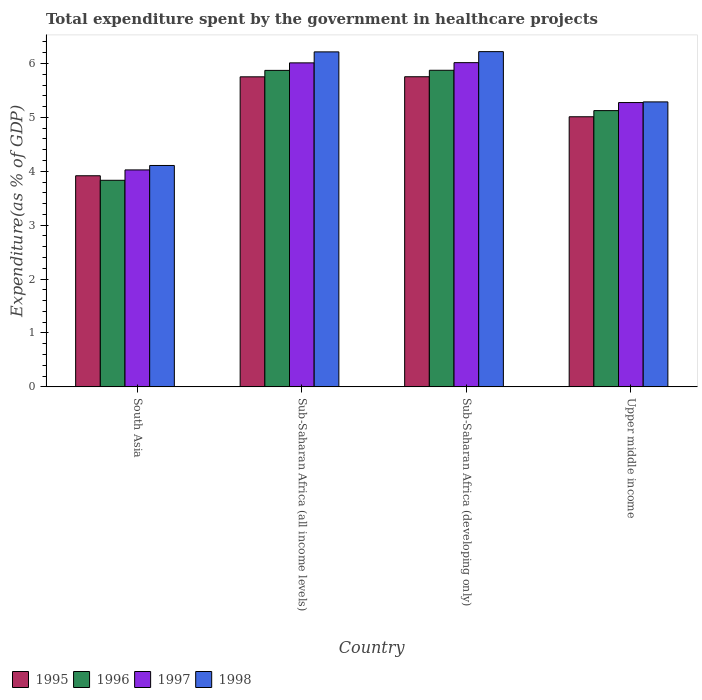How many groups of bars are there?
Keep it short and to the point. 4. How many bars are there on the 3rd tick from the left?
Provide a succinct answer. 4. How many bars are there on the 4th tick from the right?
Keep it short and to the point. 4. What is the label of the 3rd group of bars from the left?
Offer a very short reply. Sub-Saharan Africa (developing only). What is the total expenditure spent by the government in healthcare projects in 1997 in Sub-Saharan Africa (all income levels)?
Offer a very short reply. 6.01. Across all countries, what is the maximum total expenditure spent by the government in healthcare projects in 1996?
Your answer should be compact. 5.87. Across all countries, what is the minimum total expenditure spent by the government in healthcare projects in 1998?
Provide a succinct answer. 4.11. In which country was the total expenditure spent by the government in healthcare projects in 1996 maximum?
Your answer should be very brief. Sub-Saharan Africa (developing only). In which country was the total expenditure spent by the government in healthcare projects in 1996 minimum?
Provide a succinct answer. South Asia. What is the total total expenditure spent by the government in healthcare projects in 1998 in the graph?
Provide a short and direct response. 21.83. What is the difference between the total expenditure spent by the government in healthcare projects in 1998 in South Asia and that in Sub-Saharan Africa (developing only)?
Give a very brief answer. -2.11. What is the difference between the total expenditure spent by the government in healthcare projects in 1996 in Upper middle income and the total expenditure spent by the government in healthcare projects in 1997 in Sub-Saharan Africa (all income levels)?
Make the answer very short. -0.89. What is the average total expenditure spent by the government in healthcare projects in 1997 per country?
Your answer should be compact. 5.33. What is the difference between the total expenditure spent by the government in healthcare projects of/in 1995 and total expenditure spent by the government in healthcare projects of/in 1996 in Sub-Saharan Africa (all income levels)?
Your answer should be compact. -0.12. What is the ratio of the total expenditure spent by the government in healthcare projects in 1996 in South Asia to that in Sub-Saharan Africa (all income levels)?
Offer a terse response. 0.65. Is the total expenditure spent by the government in healthcare projects in 1998 in Sub-Saharan Africa (developing only) less than that in Upper middle income?
Provide a succinct answer. No. Is the difference between the total expenditure spent by the government in healthcare projects in 1995 in Sub-Saharan Africa (developing only) and Upper middle income greater than the difference between the total expenditure spent by the government in healthcare projects in 1996 in Sub-Saharan Africa (developing only) and Upper middle income?
Ensure brevity in your answer.  No. What is the difference between the highest and the second highest total expenditure spent by the government in healthcare projects in 1995?
Keep it short and to the point. -0.74. What is the difference between the highest and the lowest total expenditure spent by the government in healthcare projects in 1998?
Make the answer very short. 2.11. What does the 2nd bar from the left in South Asia represents?
Your response must be concise. 1996. What does the 4th bar from the right in Sub-Saharan Africa (all income levels) represents?
Ensure brevity in your answer.  1995. What is the difference between two consecutive major ticks on the Y-axis?
Give a very brief answer. 1. Are the values on the major ticks of Y-axis written in scientific E-notation?
Provide a succinct answer. No. Does the graph contain any zero values?
Offer a very short reply. No. What is the title of the graph?
Make the answer very short. Total expenditure spent by the government in healthcare projects. What is the label or title of the X-axis?
Make the answer very short. Country. What is the label or title of the Y-axis?
Your answer should be compact. Expenditure(as % of GDP). What is the Expenditure(as % of GDP) in 1995 in South Asia?
Your answer should be compact. 3.92. What is the Expenditure(as % of GDP) of 1996 in South Asia?
Make the answer very short. 3.83. What is the Expenditure(as % of GDP) of 1997 in South Asia?
Offer a terse response. 4.03. What is the Expenditure(as % of GDP) in 1998 in South Asia?
Keep it short and to the point. 4.11. What is the Expenditure(as % of GDP) in 1995 in Sub-Saharan Africa (all income levels)?
Make the answer very short. 5.75. What is the Expenditure(as % of GDP) of 1996 in Sub-Saharan Africa (all income levels)?
Offer a terse response. 5.87. What is the Expenditure(as % of GDP) of 1997 in Sub-Saharan Africa (all income levels)?
Give a very brief answer. 6.01. What is the Expenditure(as % of GDP) in 1998 in Sub-Saharan Africa (all income levels)?
Give a very brief answer. 6.22. What is the Expenditure(as % of GDP) of 1995 in Sub-Saharan Africa (developing only)?
Keep it short and to the point. 5.75. What is the Expenditure(as % of GDP) in 1996 in Sub-Saharan Africa (developing only)?
Make the answer very short. 5.87. What is the Expenditure(as % of GDP) in 1997 in Sub-Saharan Africa (developing only)?
Provide a short and direct response. 6.02. What is the Expenditure(as % of GDP) of 1998 in Sub-Saharan Africa (developing only)?
Your answer should be very brief. 6.22. What is the Expenditure(as % of GDP) in 1995 in Upper middle income?
Keep it short and to the point. 5.01. What is the Expenditure(as % of GDP) of 1996 in Upper middle income?
Your answer should be very brief. 5.13. What is the Expenditure(as % of GDP) of 1997 in Upper middle income?
Provide a short and direct response. 5.28. What is the Expenditure(as % of GDP) of 1998 in Upper middle income?
Provide a succinct answer. 5.29. Across all countries, what is the maximum Expenditure(as % of GDP) of 1995?
Your response must be concise. 5.75. Across all countries, what is the maximum Expenditure(as % of GDP) in 1996?
Keep it short and to the point. 5.87. Across all countries, what is the maximum Expenditure(as % of GDP) of 1997?
Give a very brief answer. 6.02. Across all countries, what is the maximum Expenditure(as % of GDP) of 1998?
Ensure brevity in your answer.  6.22. Across all countries, what is the minimum Expenditure(as % of GDP) in 1995?
Offer a terse response. 3.92. Across all countries, what is the minimum Expenditure(as % of GDP) of 1996?
Provide a short and direct response. 3.83. Across all countries, what is the minimum Expenditure(as % of GDP) in 1997?
Keep it short and to the point. 4.03. Across all countries, what is the minimum Expenditure(as % of GDP) in 1998?
Your answer should be compact. 4.11. What is the total Expenditure(as % of GDP) in 1995 in the graph?
Your answer should be compact. 20.44. What is the total Expenditure(as % of GDP) of 1996 in the graph?
Make the answer very short. 20.71. What is the total Expenditure(as % of GDP) of 1997 in the graph?
Make the answer very short. 21.33. What is the total Expenditure(as % of GDP) of 1998 in the graph?
Your response must be concise. 21.83. What is the difference between the Expenditure(as % of GDP) of 1995 in South Asia and that in Sub-Saharan Africa (all income levels)?
Ensure brevity in your answer.  -1.84. What is the difference between the Expenditure(as % of GDP) of 1996 in South Asia and that in Sub-Saharan Africa (all income levels)?
Provide a short and direct response. -2.04. What is the difference between the Expenditure(as % of GDP) of 1997 in South Asia and that in Sub-Saharan Africa (all income levels)?
Your answer should be very brief. -1.99. What is the difference between the Expenditure(as % of GDP) in 1998 in South Asia and that in Sub-Saharan Africa (all income levels)?
Your answer should be compact. -2.11. What is the difference between the Expenditure(as % of GDP) in 1995 in South Asia and that in Sub-Saharan Africa (developing only)?
Make the answer very short. -1.84. What is the difference between the Expenditure(as % of GDP) in 1996 in South Asia and that in Sub-Saharan Africa (developing only)?
Offer a terse response. -2.04. What is the difference between the Expenditure(as % of GDP) in 1997 in South Asia and that in Sub-Saharan Africa (developing only)?
Offer a very short reply. -1.99. What is the difference between the Expenditure(as % of GDP) of 1998 in South Asia and that in Sub-Saharan Africa (developing only)?
Provide a succinct answer. -2.11. What is the difference between the Expenditure(as % of GDP) in 1995 in South Asia and that in Upper middle income?
Provide a succinct answer. -1.09. What is the difference between the Expenditure(as % of GDP) of 1996 in South Asia and that in Upper middle income?
Offer a terse response. -1.29. What is the difference between the Expenditure(as % of GDP) of 1997 in South Asia and that in Upper middle income?
Keep it short and to the point. -1.25. What is the difference between the Expenditure(as % of GDP) of 1998 in South Asia and that in Upper middle income?
Keep it short and to the point. -1.18. What is the difference between the Expenditure(as % of GDP) in 1995 in Sub-Saharan Africa (all income levels) and that in Sub-Saharan Africa (developing only)?
Offer a very short reply. -0. What is the difference between the Expenditure(as % of GDP) of 1996 in Sub-Saharan Africa (all income levels) and that in Sub-Saharan Africa (developing only)?
Provide a short and direct response. -0. What is the difference between the Expenditure(as % of GDP) of 1997 in Sub-Saharan Africa (all income levels) and that in Sub-Saharan Africa (developing only)?
Ensure brevity in your answer.  -0. What is the difference between the Expenditure(as % of GDP) of 1998 in Sub-Saharan Africa (all income levels) and that in Sub-Saharan Africa (developing only)?
Give a very brief answer. -0. What is the difference between the Expenditure(as % of GDP) of 1995 in Sub-Saharan Africa (all income levels) and that in Upper middle income?
Your response must be concise. 0.74. What is the difference between the Expenditure(as % of GDP) in 1996 in Sub-Saharan Africa (all income levels) and that in Upper middle income?
Provide a succinct answer. 0.75. What is the difference between the Expenditure(as % of GDP) in 1997 in Sub-Saharan Africa (all income levels) and that in Upper middle income?
Your answer should be compact. 0.74. What is the difference between the Expenditure(as % of GDP) of 1998 in Sub-Saharan Africa (all income levels) and that in Upper middle income?
Provide a succinct answer. 0.93. What is the difference between the Expenditure(as % of GDP) of 1995 in Sub-Saharan Africa (developing only) and that in Upper middle income?
Make the answer very short. 0.74. What is the difference between the Expenditure(as % of GDP) in 1996 in Sub-Saharan Africa (developing only) and that in Upper middle income?
Offer a terse response. 0.75. What is the difference between the Expenditure(as % of GDP) of 1997 in Sub-Saharan Africa (developing only) and that in Upper middle income?
Provide a short and direct response. 0.74. What is the difference between the Expenditure(as % of GDP) of 1998 in Sub-Saharan Africa (developing only) and that in Upper middle income?
Provide a short and direct response. 0.93. What is the difference between the Expenditure(as % of GDP) in 1995 in South Asia and the Expenditure(as % of GDP) in 1996 in Sub-Saharan Africa (all income levels)?
Make the answer very short. -1.96. What is the difference between the Expenditure(as % of GDP) in 1995 in South Asia and the Expenditure(as % of GDP) in 1997 in Sub-Saharan Africa (all income levels)?
Your answer should be compact. -2.09. What is the difference between the Expenditure(as % of GDP) of 1995 in South Asia and the Expenditure(as % of GDP) of 1998 in Sub-Saharan Africa (all income levels)?
Give a very brief answer. -2.3. What is the difference between the Expenditure(as % of GDP) of 1996 in South Asia and the Expenditure(as % of GDP) of 1997 in Sub-Saharan Africa (all income levels)?
Make the answer very short. -2.18. What is the difference between the Expenditure(as % of GDP) of 1996 in South Asia and the Expenditure(as % of GDP) of 1998 in Sub-Saharan Africa (all income levels)?
Provide a succinct answer. -2.38. What is the difference between the Expenditure(as % of GDP) of 1997 in South Asia and the Expenditure(as % of GDP) of 1998 in Sub-Saharan Africa (all income levels)?
Provide a succinct answer. -2.19. What is the difference between the Expenditure(as % of GDP) of 1995 in South Asia and the Expenditure(as % of GDP) of 1996 in Sub-Saharan Africa (developing only)?
Your answer should be very brief. -1.96. What is the difference between the Expenditure(as % of GDP) in 1995 in South Asia and the Expenditure(as % of GDP) in 1997 in Sub-Saharan Africa (developing only)?
Ensure brevity in your answer.  -2.1. What is the difference between the Expenditure(as % of GDP) of 1995 in South Asia and the Expenditure(as % of GDP) of 1998 in Sub-Saharan Africa (developing only)?
Offer a terse response. -2.3. What is the difference between the Expenditure(as % of GDP) of 1996 in South Asia and the Expenditure(as % of GDP) of 1997 in Sub-Saharan Africa (developing only)?
Give a very brief answer. -2.18. What is the difference between the Expenditure(as % of GDP) of 1996 in South Asia and the Expenditure(as % of GDP) of 1998 in Sub-Saharan Africa (developing only)?
Provide a succinct answer. -2.39. What is the difference between the Expenditure(as % of GDP) in 1997 in South Asia and the Expenditure(as % of GDP) in 1998 in Sub-Saharan Africa (developing only)?
Make the answer very short. -2.19. What is the difference between the Expenditure(as % of GDP) in 1995 in South Asia and the Expenditure(as % of GDP) in 1996 in Upper middle income?
Offer a very short reply. -1.21. What is the difference between the Expenditure(as % of GDP) of 1995 in South Asia and the Expenditure(as % of GDP) of 1997 in Upper middle income?
Offer a terse response. -1.36. What is the difference between the Expenditure(as % of GDP) in 1995 in South Asia and the Expenditure(as % of GDP) in 1998 in Upper middle income?
Your answer should be compact. -1.37. What is the difference between the Expenditure(as % of GDP) in 1996 in South Asia and the Expenditure(as % of GDP) in 1997 in Upper middle income?
Provide a succinct answer. -1.44. What is the difference between the Expenditure(as % of GDP) of 1996 in South Asia and the Expenditure(as % of GDP) of 1998 in Upper middle income?
Your answer should be compact. -1.45. What is the difference between the Expenditure(as % of GDP) in 1997 in South Asia and the Expenditure(as % of GDP) in 1998 in Upper middle income?
Your answer should be compact. -1.26. What is the difference between the Expenditure(as % of GDP) in 1995 in Sub-Saharan Africa (all income levels) and the Expenditure(as % of GDP) in 1996 in Sub-Saharan Africa (developing only)?
Provide a succinct answer. -0.12. What is the difference between the Expenditure(as % of GDP) of 1995 in Sub-Saharan Africa (all income levels) and the Expenditure(as % of GDP) of 1997 in Sub-Saharan Africa (developing only)?
Give a very brief answer. -0.26. What is the difference between the Expenditure(as % of GDP) in 1995 in Sub-Saharan Africa (all income levels) and the Expenditure(as % of GDP) in 1998 in Sub-Saharan Africa (developing only)?
Make the answer very short. -0.47. What is the difference between the Expenditure(as % of GDP) in 1996 in Sub-Saharan Africa (all income levels) and the Expenditure(as % of GDP) in 1997 in Sub-Saharan Africa (developing only)?
Your answer should be very brief. -0.14. What is the difference between the Expenditure(as % of GDP) in 1996 in Sub-Saharan Africa (all income levels) and the Expenditure(as % of GDP) in 1998 in Sub-Saharan Africa (developing only)?
Provide a short and direct response. -0.35. What is the difference between the Expenditure(as % of GDP) in 1997 in Sub-Saharan Africa (all income levels) and the Expenditure(as % of GDP) in 1998 in Sub-Saharan Africa (developing only)?
Offer a terse response. -0.21. What is the difference between the Expenditure(as % of GDP) of 1995 in Sub-Saharan Africa (all income levels) and the Expenditure(as % of GDP) of 1996 in Upper middle income?
Keep it short and to the point. 0.63. What is the difference between the Expenditure(as % of GDP) in 1995 in Sub-Saharan Africa (all income levels) and the Expenditure(as % of GDP) in 1997 in Upper middle income?
Provide a short and direct response. 0.48. What is the difference between the Expenditure(as % of GDP) of 1995 in Sub-Saharan Africa (all income levels) and the Expenditure(as % of GDP) of 1998 in Upper middle income?
Give a very brief answer. 0.47. What is the difference between the Expenditure(as % of GDP) in 1996 in Sub-Saharan Africa (all income levels) and the Expenditure(as % of GDP) in 1997 in Upper middle income?
Make the answer very short. 0.6. What is the difference between the Expenditure(as % of GDP) of 1996 in Sub-Saharan Africa (all income levels) and the Expenditure(as % of GDP) of 1998 in Upper middle income?
Ensure brevity in your answer.  0.58. What is the difference between the Expenditure(as % of GDP) in 1997 in Sub-Saharan Africa (all income levels) and the Expenditure(as % of GDP) in 1998 in Upper middle income?
Provide a short and direct response. 0.72. What is the difference between the Expenditure(as % of GDP) in 1995 in Sub-Saharan Africa (developing only) and the Expenditure(as % of GDP) in 1996 in Upper middle income?
Your answer should be very brief. 0.63. What is the difference between the Expenditure(as % of GDP) of 1995 in Sub-Saharan Africa (developing only) and the Expenditure(as % of GDP) of 1997 in Upper middle income?
Your answer should be compact. 0.48. What is the difference between the Expenditure(as % of GDP) in 1995 in Sub-Saharan Africa (developing only) and the Expenditure(as % of GDP) in 1998 in Upper middle income?
Keep it short and to the point. 0.47. What is the difference between the Expenditure(as % of GDP) in 1996 in Sub-Saharan Africa (developing only) and the Expenditure(as % of GDP) in 1997 in Upper middle income?
Give a very brief answer. 0.6. What is the difference between the Expenditure(as % of GDP) in 1996 in Sub-Saharan Africa (developing only) and the Expenditure(as % of GDP) in 1998 in Upper middle income?
Ensure brevity in your answer.  0.59. What is the difference between the Expenditure(as % of GDP) in 1997 in Sub-Saharan Africa (developing only) and the Expenditure(as % of GDP) in 1998 in Upper middle income?
Provide a succinct answer. 0.73. What is the average Expenditure(as % of GDP) in 1995 per country?
Keep it short and to the point. 5.11. What is the average Expenditure(as % of GDP) in 1996 per country?
Offer a terse response. 5.18. What is the average Expenditure(as % of GDP) of 1997 per country?
Ensure brevity in your answer.  5.33. What is the average Expenditure(as % of GDP) in 1998 per country?
Your response must be concise. 5.46. What is the difference between the Expenditure(as % of GDP) in 1995 and Expenditure(as % of GDP) in 1996 in South Asia?
Give a very brief answer. 0.08. What is the difference between the Expenditure(as % of GDP) in 1995 and Expenditure(as % of GDP) in 1997 in South Asia?
Make the answer very short. -0.11. What is the difference between the Expenditure(as % of GDP) in 1995 and Expenditure(as % of GDP) in 1998 in South Asia?
Keep it short and to the point. -0.19. What is the difference between the Expenditure(as % of GDP) in 1996 and Expenditure(as % of GDP) in 1997 in South Asia?
Keep it short and to the point. -0.19. What is the difference between the Expenditure(as % of GDP) of 1996 and Expenditure(as % of GDP) of 1998 in South Asia?
Keep it short and to the point. -0.27. What is the difference between the Expenditure(as % of GDP) in 1997 and Expenditure(as % of GDP) in 1998 in South Asia?
Your answer should be very brief. -0.08. What is the difference between the Expenditure(as % of GDP) in 1995 and Expenditure(as % of GDP) in 1996 in Sub-Saharan Africa (all income levels)?
Keep it short and to the point. -0.12. What is the difference between the Expenditure(as % of GDP) of 1995 and Expenditure(as % of GDP) of 1997 in Sub-Saharan Africa (all income levels)?
Make the answer very short. -0.26. What is the difference between the Expenditure(as % of GDP) in 1995 and Expenditure(as % of GDP) in 1998 in Sub-Saharan Africa (all income levels)?
Ensure brevity in your answer.  -0.46. What is the difference between the Expenditure(as % of GDP) in 1996 and Expenditure(as % of GDP) in 1997 in Sub-Saharan Africa (all income levels)?
Your answer should be very brief. -0.14. What is the difference between the Expenditure(as % of GDP) in 1996 and Expenditure(as % of GDP) in 1998 in Sub-Saharan Africa (all income levels)?
Ensure brevity in your answer.  -0.34. What is the difference between the Expenditure(as % of GDP) in 1997 and Expenditure(as % of GDP) in 1998 in Sub-Saharan Africa (all income levels)?
Provide a short and direct response. -0.2. What is the difference between the Expenditure(as % of GDP) in 1995 and Expenditure(as % of GDP) in 1996 in Sub-Saharan Africa (developing only)?
Offer a terse response. -0.12. What is the difference between the Expenditure(as % of GDP) in 1995 and Expenditure(as % of GDP) in 1997 in Sub-Saharan Africa (developing only)?
Your answer should be very brief. -0.26. What is the difference between the Expenditure(as % of GDP) of 1995 and Expenditure(as % of GDP) of 1998 in Sub-Saharan Africa (developing only)?
Your answer should be compact. -0.47. What is the difference between the Expenditure(as % of GDP) in 1996 and Expenditure(as % of GDP) in 1997 in Sub-Saharan Africa (developing only)?
Provide a succinct answer. -0.14. What is the difference between the Expenditure(as % of GDP) of 1996 and Expenditure(as % of GDP) of 1998 in Sub-Saharan Africa (developing only)?
Your answer should be very brief. -0.35. What is the difference between the Expenditure(as % of GDP) in 1997 and Expenditure(as % of GDP) in 1998 in Sub-Saharan Africa (developing only)?
Give a very brief answer. -0.2. What is the difference between the Expenditure(as % of GDP) of 1995 and Expenditure(as % of GDP) of 1996 in Upper middle income?
Provide a succinct answer. -0.11. What is the difference between the Expenditure(as % of GDP) in 1995 and Expenditure(as % of GDP) in 1997 in Upper middle income?
Your response must be concise. -0.26. What is the difference between the Expenditure(as % of GDP) of 1995 and Expenditure(as % of GDP) of 1998 in Upper middle income?
Ensure brevity in your answer.  -0.28. What is the difference between the Expenditure(as % of GDP) of 1996 and Expenditure(as % of GDP) of 1997 in Upper middle income?
Offer a very short reply. -0.15. What is the difference between the Expenditure(as % of GDP) in 1996 and Expenditure(as % of GDP) in 1998 in Upper middle income?
Give a very brief answer. -0.16. What is the difference between the Expenditure(as % of GDP) in 1997 and Expenditure(as % of GDP) in 1998 in Upper middle income?
Your answer should be very brief. -0.01. What is the ratio of the Expenditure(as % of GDP) of 1995 in South Asia to that in Sub-Saharan Africa (all income levels)?
Make the answer very short. 0.68. What is the ratio of the Expenditure(as % of GDP) of 1996 in South Asia to that in Sub-Saharan Africa (all income levels)?
Make the answer very short. 0.65. What is the ratio of the Expenditure(as % of GDP) of 1997 in South Asia to that in Sub-Saharan Africa (all income levels)?
Your answer should be compact. 0.67. What is the ratio of the Expenditure(as % of GDP) of 1998 in South Asia to that in Sub-Saharan Africa (all income levels)?
Offer a terse response. 0.66. What is the ratio of the Expenditure(as % of GDP) of 1995 in South Asia to that in Sub-Saharan Africa (developing only)?
Provide a short and direct response. 0.68. What is the ratio of the Expenditure(as % of GDP) in 1996 in South Asia to that in Sub-Saharan Africa (developing only)?
Make the answer very short. 0.65. What is the ratio of the Expenditure(as % of GDP) in 1997 in South Asia to that in Sub-Saharan Africa (developing only)?
Ensure brevity in your answer.  0.67. What is the ratio of the Expenditure(as % of GDP) in 1998 in South Asia to that in Sub-Saharan Africa (developing only)?
Make the answer very short. 0.66. What is the ratio of the Expenditure(as % of GDP) in 1995 in South Asia to that in Upper middle income?
Provide a short and direct response. 0.78. What is the ratio of the Expenditure(as % of GDP) of 1996 in South Asia to that in Upper middle income?
Give a very brief answer. 0.75. What is the ratio of the Expenditure(as % of GDP) of 1997 in South Asia to that in Upper middle income?
Offer a terse response. 0.76. What is the ratio of the Expenditure(as % of GDP) of 1998 in South Asia to that in Upper middle income?
Offer a terse response. 0.78. What is the ratio of the Expenditure(as % of GDP) of 1995 in Sub-Saharan Africa (all income levels) to that in Sub-Saharan Africa (developing only)?
Your answer should be very brief. 1. What is the ratio of the Expenditure(as % of GDP) of 1998 in Sub-Saharan Africa (all income levels) to that in Sub-Saharan Africa (developing only)?
Ensure brevity in your answer.  1. What is the ratio of the Expenditure(as % of GDP) of 1995 in Sub-Saharan Africa (all income levels) to that in Upper middle income?
Your response must be concise. 1.15. What is the ratio of the Expenditure(as % of GDP) of 1996 in Sub-Saharan Africa (all income levels) to that in Upper middle income?
Make the answer very short. 1.15. What is the ratio of the Expenditure(as % of GDP) in 1997 in Sub-Saharan Africa (all income levels) to that in Upper middle income?
Your response must be concise. 1.14. What is the ratio of the Expenditure(as % of GDP) of 1998 in Sub-Saharan Africa (all income levels) to that in Upper middle income?
Your answer should be compact. 1.18. What is the ratio of the Expenditure(as % of GDP) in 1995 in Sub-Saharan Africa (developing only) to that in Upper middle income?
Keep it short and to the point. 1.15. What is the ratio of the Expenditure(as % of GDP) in 1996 in Sub-Saharan Africa (developing only) to that in Upper middle income?
Make the answer very short. 1.15. What is the ratio of the Expenditure(as % of GDP) of 1997 in Sub-Saharan Africa (developing only) to that in Upper middle income?
Your response must be concise. 1.14. What is the ratio of the Expenditure(as % of GDP) in 1998 in Sub-Saharan Africa (developing only) to that in Upper middle income?
Make the answer very short. 1.18. What is the difference between the highest and the second highest Expenditure(as % of GDP) of 1995?
Offer a terse response. 0. What is the difference between the highest and the second highest Expenditure(as % of GDP) of 1996?
Provide a succinct answer. 0. What is the difference between the highest and the second highest Expenditure(as % of GDP) of 1997?
Give a very brief answer. 0. What is the difference between the highest and the second highest Expenditure(as % of GDP) in 1998?
Offer a terse response. 0. What is the difference between the highest and the lowest Expenditure(as % of GDP) of 1995?
Keep it short and to the point. 1.84. What is the difference between the highest and the lowest Expenditure(as % of GDP) of 1996?
Offer a terse response. 2.04. What is the difference between the highest and the lowest Expenditure(as % of GDP) of 1997?
Ensure brevity in your answer.  1.99. What is the difference between the highest and the lowest Expenditure(as % of GDP) in 1998?
Provide a short and direct response. 2.11. 